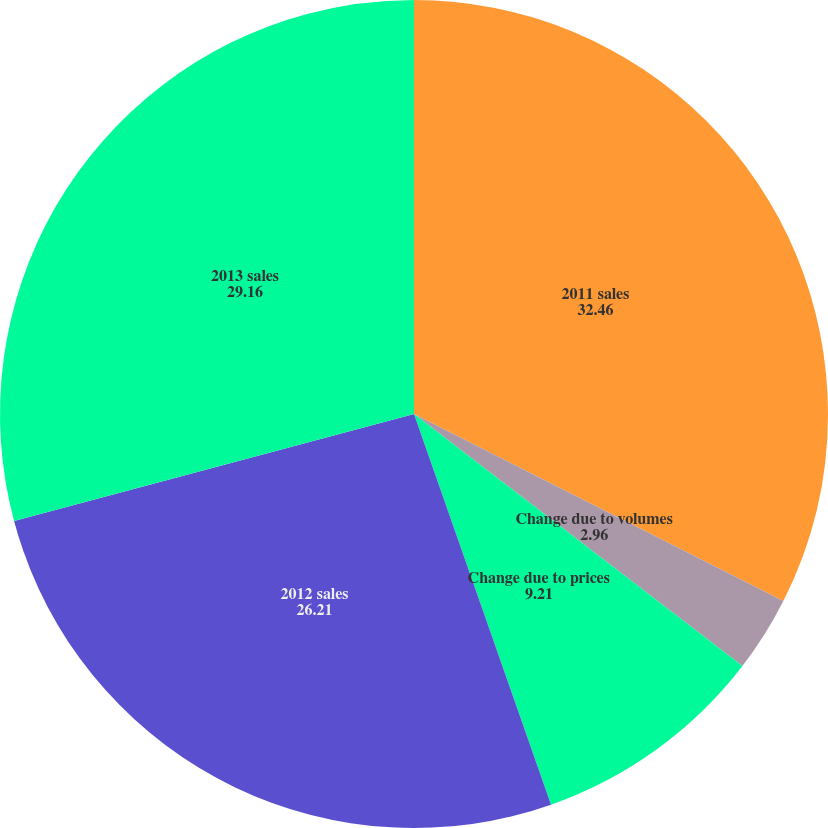Convert chart to OTSL. <chart><loc_0><loc_0><loc_500><loc_500><pie_chart><fcel>2011 sales<fcel>Change due to volumes<fcel>Change due to prices<fcel>2012 sales<fcel>2013 sales<nl><fcel>32.46%<fcel>2.96%<fcel>9.21%<fcel>26.21%<fcel>29.16%<nl></chart> 